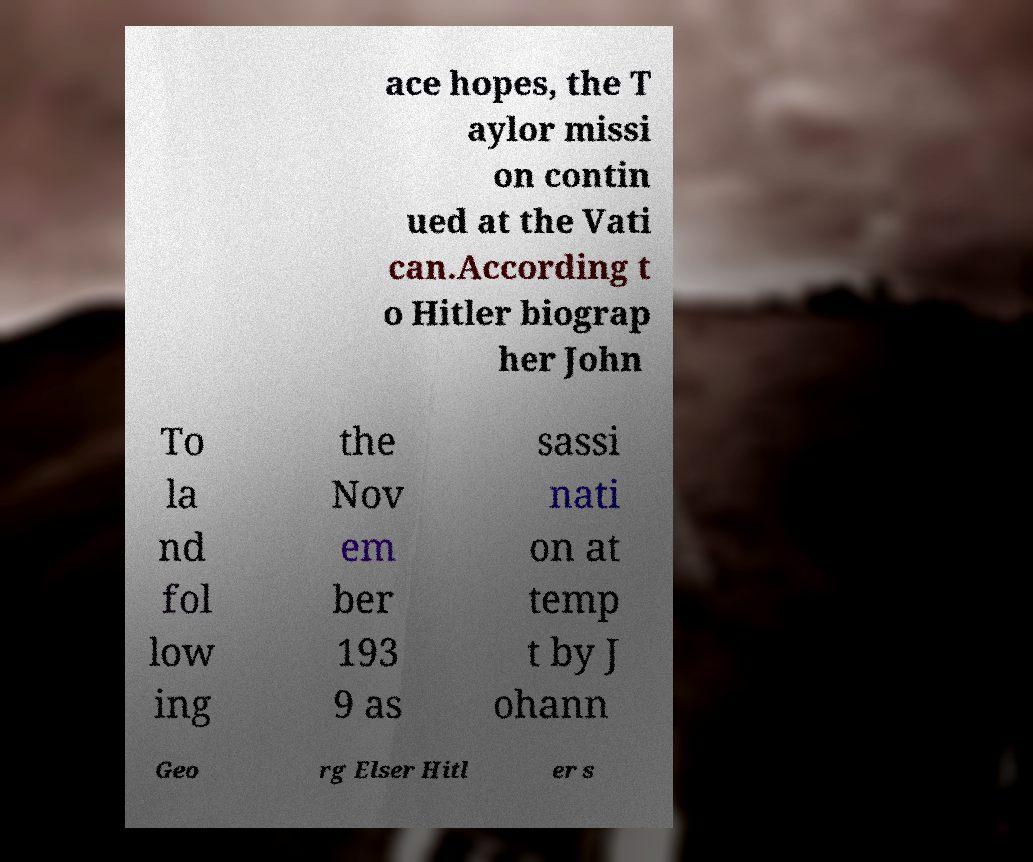Can you read and provide the text displayed in the image?This photo seems to have some interesting text. Can you extract and type it out for me? ace hopes, the T aylor missi on contin ued at the Vati can.According t o Hitler biograp her John To la nd fol low ing the Nov em ber 193 9 as sassi nati on at temp t by J ohann Geo rg Elser Hitl er s 